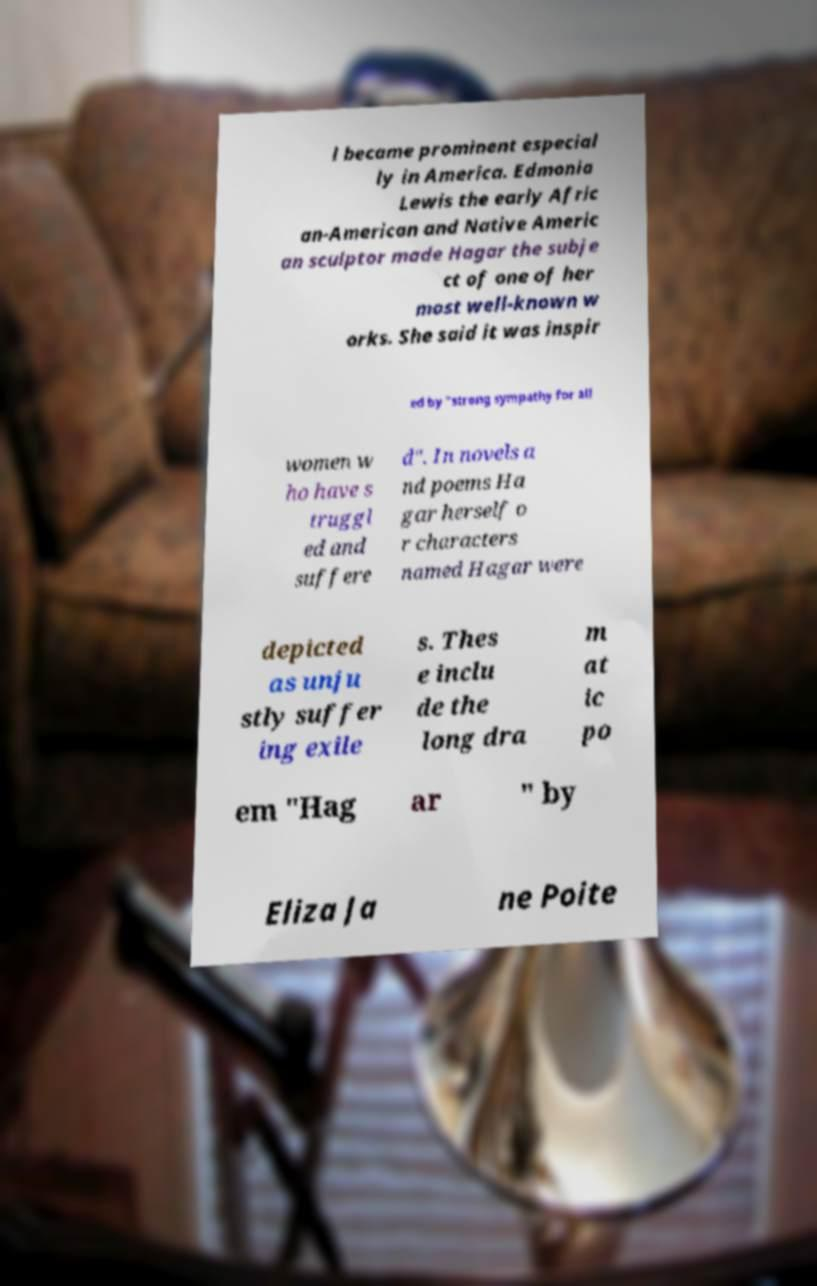Can you read and provide the text displayed in the image?This photo seems to have some interesting text. Can you extract and type it out for me? l became prominent especial ly in America. Edmonia Lewis the early Afric an-American and Native Americ an sculptor made Hagar the subje ct of one of her most well-known w orks. She said it was inspir ed by "strong sympathy for all women w ho have s truggl ed and suffere d". In novels a nd poems Ha gar herself o r characters named Hagar were depicted as unju stly suffer ing exile s. Thes e inclu de the long dra m at ic po em "Hag ar " by Eliza Ja ne Poite 